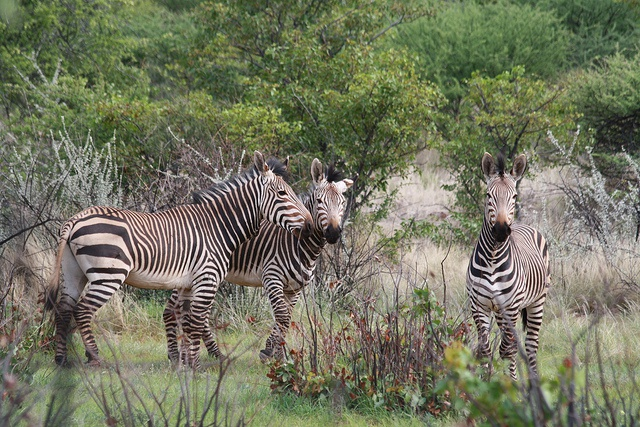Describe the objects in this image and their specific colors. I can see zebra in green, gray, black, lightgray, and darkgray tones, zebra in green, gray, darkgray, black, and lightgray tones, and zebra in green, black, gray, and darkgray tones in this image. 